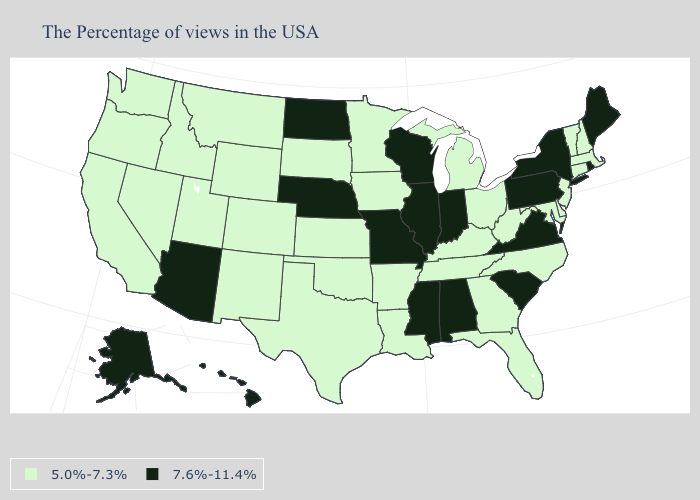Among the states that border Nevada , which have the lowest value?
Give a very brief answer. Utah, Idaho, California, Oregon. What is the value of Michigan?
Short answer required. 5.0%-7.3%. Does Pennsylvania have the lowest value in the Northeast?
Keep it brief. No. How many symbols are there in the legend?
Keep it brief. 2. What is the highest value in the MidWest ?
Be succinct. 7.6%-11.4%. Which states have the highest value in the USA?
Give a very brief answer. Maine, Rhode Island, New York, Pennsylvania, Virginia, South Carolina, Indiana, Alabama, Wisconsin, Illinois, Mississippi, Missouri, Nebraska, North Dakota, Arizona, Alaska, Hawaii. Which states have the lowest value in the USA?
Concise answer only. Massachusetts, New Hampshire, Vermont, Connecticut, New Jersey, Delaware, Maryland, North Carolina, West Virginia, Ohio, Florida, Georgia, Michigan, Kentucky, Tennessee, Louisiana, Arkansas, Minnesota, Iowa, Kansas, Oklahoma, Texas, South Dakota, Wyoming, Colorado, New Mexico, Utah, Montana, Idaho, Nevada, California, Washington, Oregon. What is the value of Georgia?
Write a very short answer. 5.0%-7.3%. Which states have the highest value in the USA?
Short answer required. Maine, Rhode Island, New York, Pennsylvania, Virginia, South Carolina, Indiana, Alabama, Wisconsin, Illinois, Mississippi, Missouri, Nebraska, North Dakota, Arizona, Alaska, Hawaii. Name the states that have a value in the range 5.0%-7.3%?
Write a very short answer. Massachusetts, New Hampshire, Vermont, Connecticut, New Jersey, Delaware, Maryland, North Carolina, West Virginia, Ohio, Florida, Georgia, Michigan, Kentucky, Tennessee, Louisiana, Arkansas, Minnesota, Iowa, Kansas, Oklahoma, Texas, South Dakota, Wyoming, Colorado, New Mexico, Utah, Montana, Idaho, Nevada, California, Washington, Oregon. Does the first symbol in the legend represent the smallest category?
Write a very short answer. Yes. What is the value of Illinois?
Be succinct. 7.6%-11.4%. Is the legend a continuous bar?
Write a very short answer. No. Name the states that have a value in the range 7.6%-11.4%?
Give a very brief answer. Maine, Rhode Island, New York, Pennsylvania, Virginia, South Carolina, Indiana, Alabama, Wisconsin, Illinois, Mississippi, Missouri, Nebraska, North Dakota, Arizona, Alaska, Hawaii. Among the states that border North Carolina , which have the lowest value?
Concise answer only. Georgia, Tennessee. 